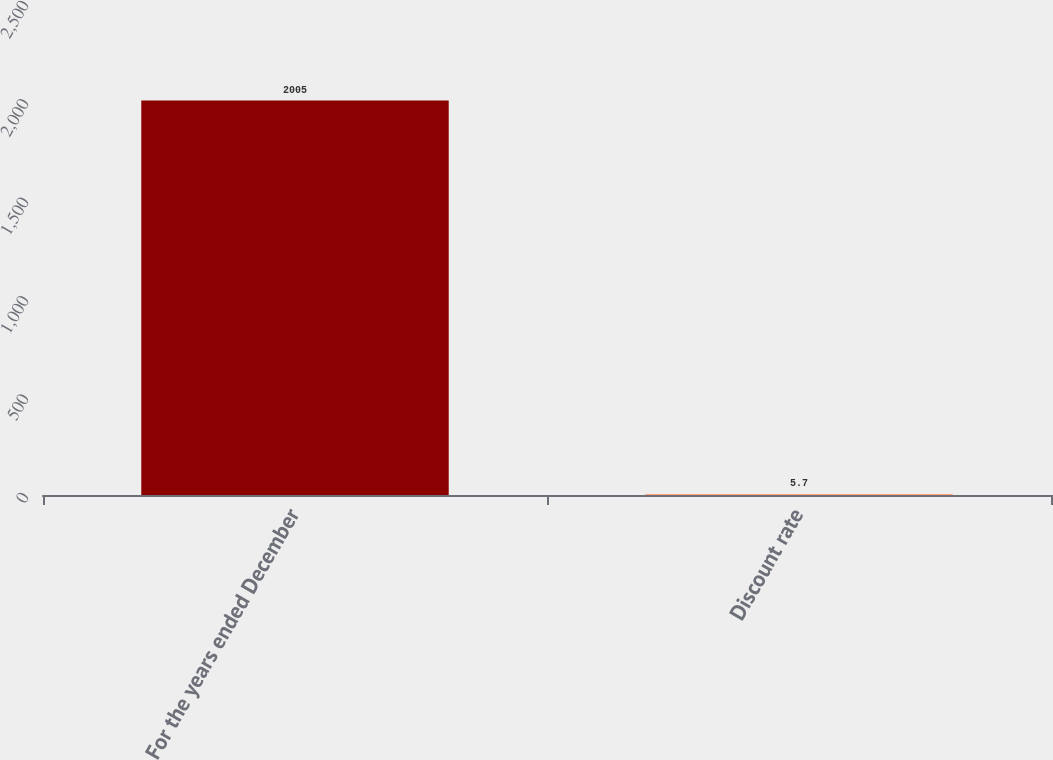Convert chart. <chart><loc_0><loc_0><loc_500><loc_500><bar_chart><fcel>For the years ended December<fcel>Discount rate<nl><fcel>2005<fcel>5.7<nl></chart> 